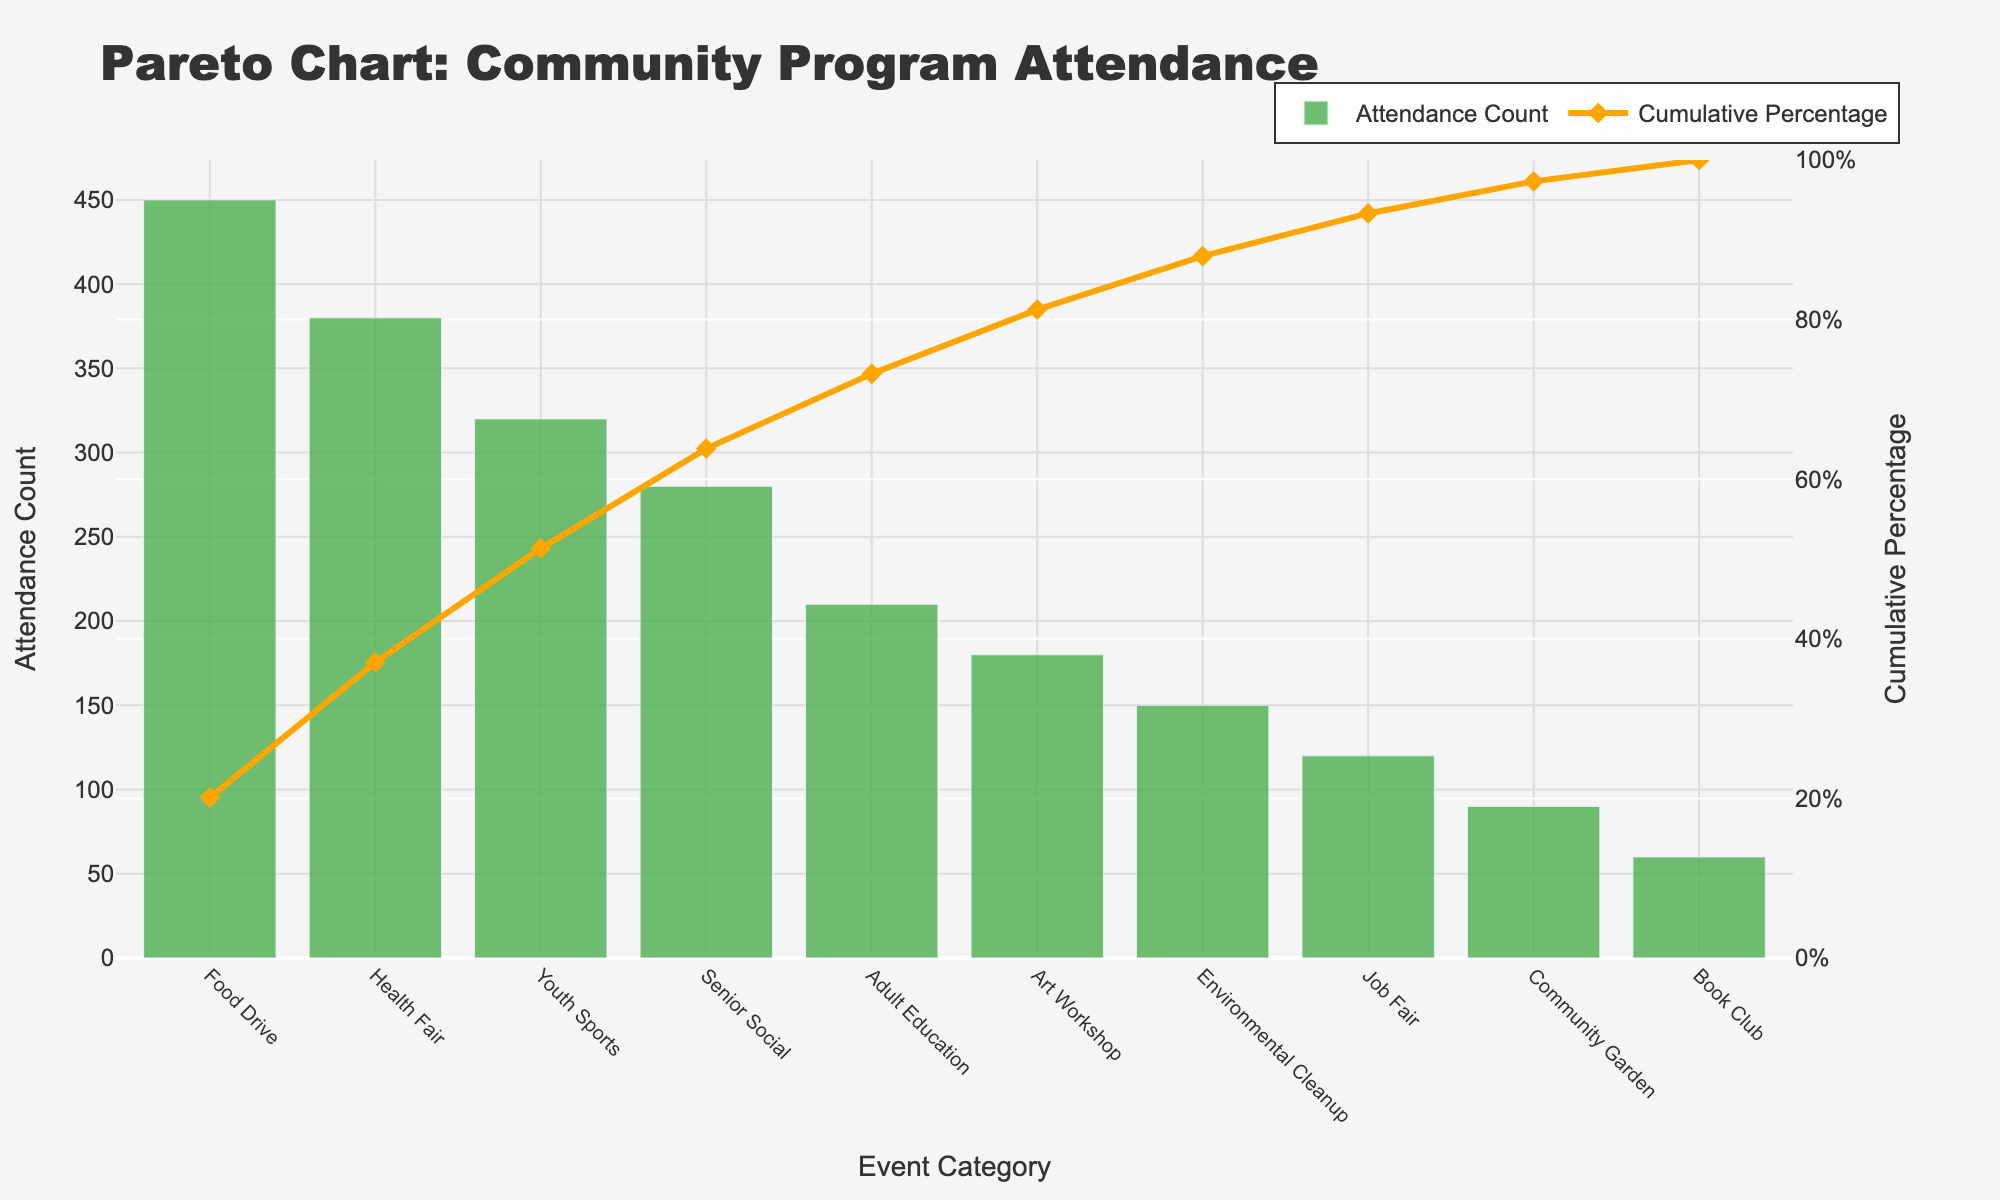What is the title of the figure? The title of the figure is located at the top of the chart. It reads "Pareto Chart: Community Program Attendance".
Answer: Pareto Chart: Community Program Attendance Which event category has the highest attendance count? The event category with the highest attendance count is located at the far left of the bar chart. It is labeled "Food Drive" with a count of 450.
Answer: Food Drive What is the cumulative percentage for "Health Fair"? Find "Health Fair" on the x-axis and follow the line chart vertically upwards. The red diamond marker indicates the cumulative percentage, which reads approximately 47%.
Answer: 47% How many event categories are represented in the chart? Count the number of distinct bars on the x-axis. There are 10 bars, corresponding to 10 event categories.
Answer: 10 What is the attendance count for "Art Workshop"? Locate "Art Workshop" on the x-axis and check the height of the corresponding green bar. The attendance count is labeled 180.
Answer: 180 Which event category contributed to crossing a cumulative percentage of 50%? Follow the cumulative percentage line (orange) and find the event category where the 50% mark is exceeded. This occurs between "Health Fair" (47%) and "Youth Sports" (approx. 69%). So, it’s "Youth Sports".
Answer: Youth Sports Compare the attendance count of "Senior Social" to "Adult Education". Which one is higher? Find the bars for both "Senior Social" and "Adult Education". The heights show that "Senior Social" (280) is higher than "Adult Education" (210).
Answer: Senior Social What is the cumulative percentage after the first three event categories? Sum the cumulative percentages of the first three bars from the left (Food Drive, Health Fair, Youth Sports). The cumulative percentages are 24%, 47%, and 69%, respectively.
Answer: 69% What is the difference in attendance count between "Job Fair" and "Community Garden"? Locate the bars for "Job Fair" and "Community Garden" and subtract the counts (120 - 90).
Answer: 30 Which event categories fall below the cumulative percentage of 75%? Look for event categories where the cumulative percentage is below 75%. These include "Food Drive", "Health Fair", "Youth Sports", "Senior Social", and "Adult Education".
Answer: Food Drive, Health Fair, Youth Sports, Senior Social, Adult Education 